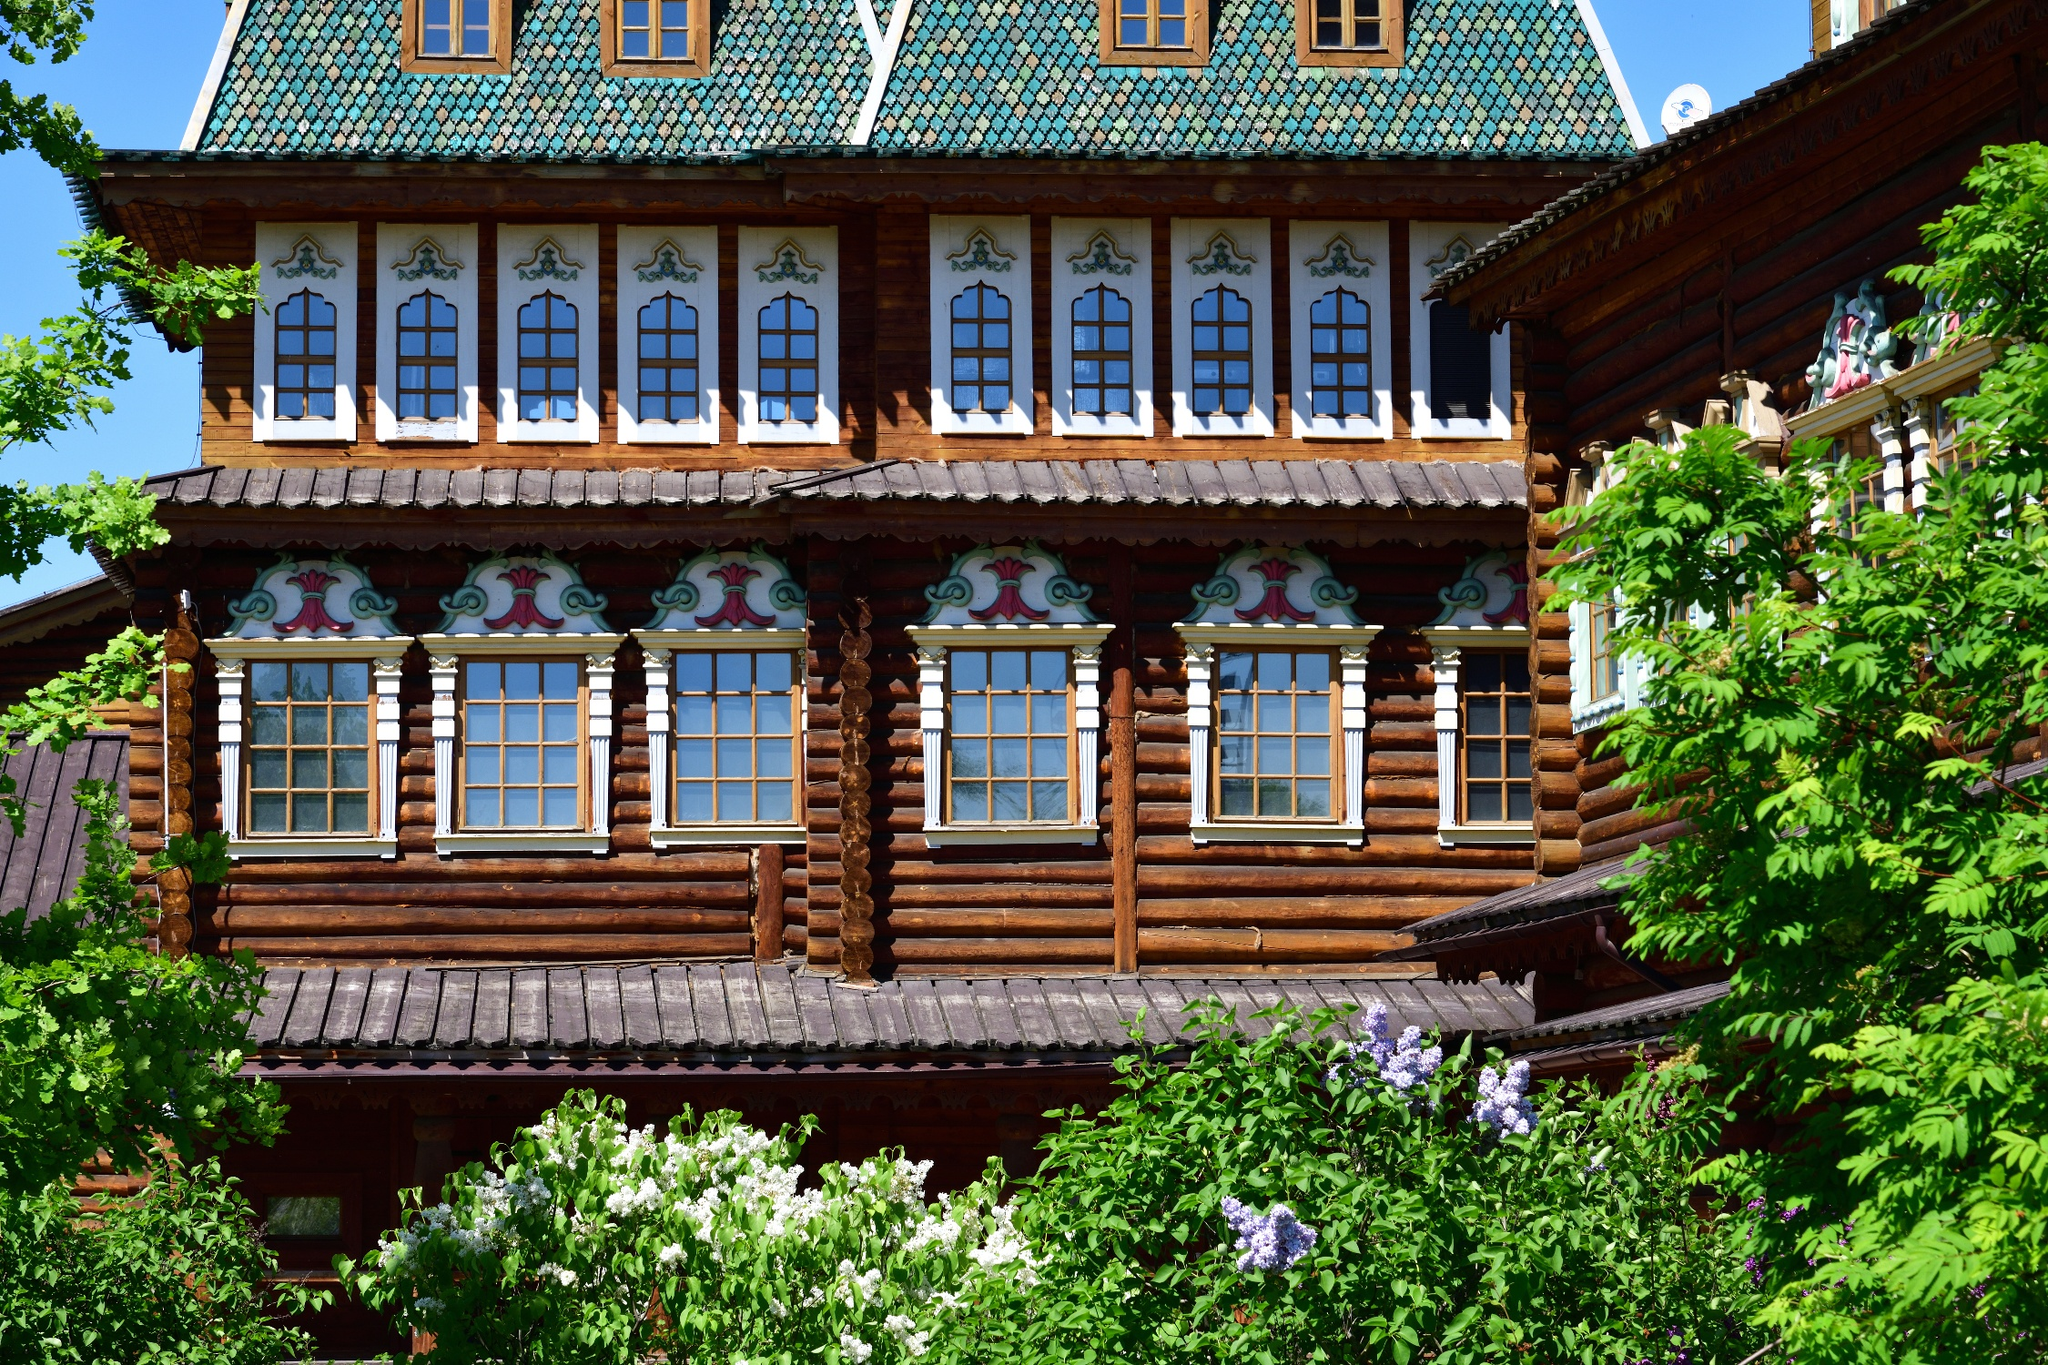Can you tell me more about the historical importance of this building? The Wooden Palace of Tsar Alexei Mikhailovich, often hailed as a masterpiece of Russian wooden architecture, served as a royal residence in the 17th century. Not only is it a symbol of Tsar Alexei's reign, but it also reflects the social and cultural atmosphere of Russia during that era. This palace is famous for its intricate craftsmanship and the way it complements its natural surroundings, showcasing the advanced wood construction techniques of its time which were emblematic of Russian artistry in wooden architecture. 